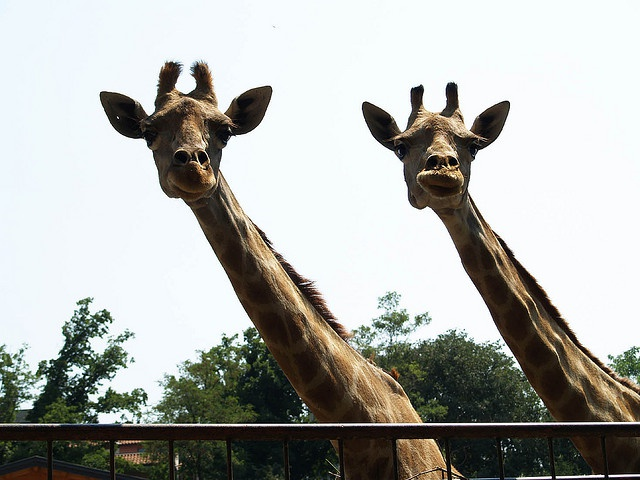Describe the objects in this image and their specific colors. I can see giraffe in white, black, tan, and gray tones and giraffe in white, black, gray, and tan tones in this image. 